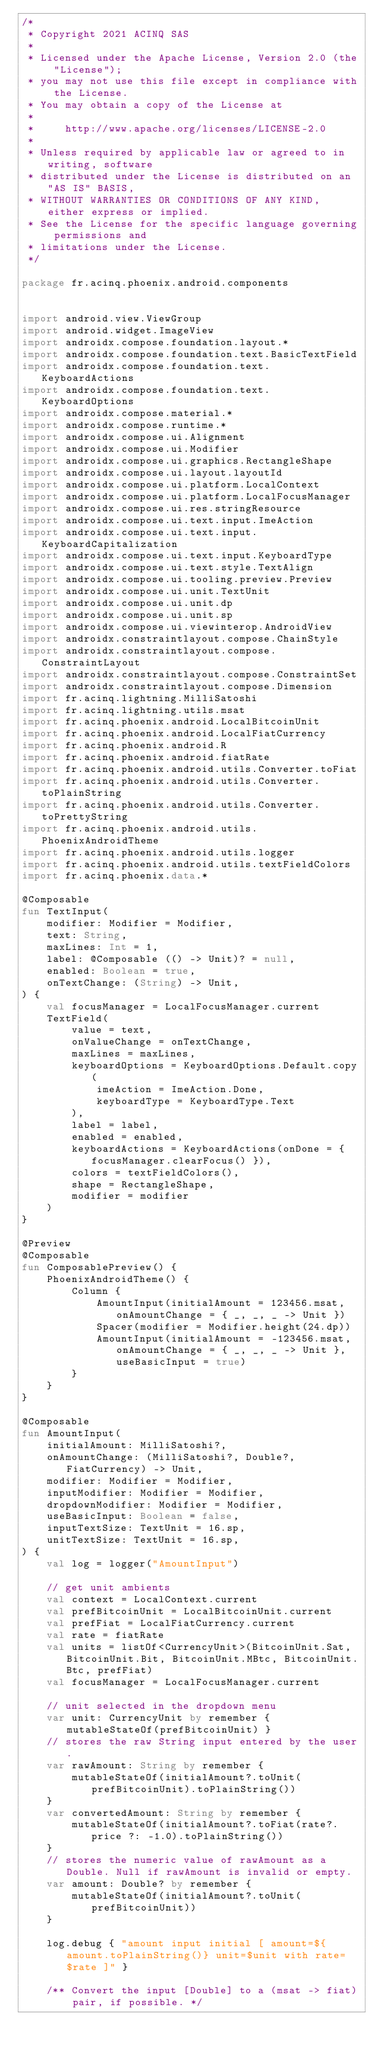Convert code to text. <code><loc_0><loc_0><loc_500><loc_500><_Kotlin_>/*
 * Copyright 2021 ACINQ SAS
 *
 * Licensed under the Apache License, Version 2.0 (the "License");
 * you may not use this file except in compliance with the License.
 * You may obtain a copy of the License at
 *
 *     http://www.apache.org/licenses/LICENSE-2.0
 *
 * Unless required by applicable law or agreed to in writing, software
 * distributed under the License is distributed on an "AS IS" BASIS,
 * WITHOUT WARRANTIES OR CONDITIONS OF ANY KIND, either express or implied.
 * See the License for the specific language governing permissions and
 * limitations under the License.
 */

package fr.acinq.phoenix.android.components


import android.view.ViewGroup
import android.widget.ImageView
import androidx.compose.foundation.layout.*
import androidx.compose.foundation.text.BasicTextField
import androidx.compose.foundation.text.KeyboardActions
import androidx.compose.foundation.text.KeyboardOptions
import androidx.compose.material.*
import androidx.compose.runtime.*
import androidx.compose.ui.Alignment
import androidx.compose.ui.Modifier
import androidx.compose.ui.graphics.RectangleShape
import androidx.compose.ui.layout.layoutId
import androidx.compose.ui.platform.LocalContext
import androidx.compose.ui.platform.LocalFocusManager
import androidx.compose.ui.res.stringResource
import androidx.compose.ui.text.input.ImeAction
import androidx.compose.ui.text.input.KeyboardCapitalization
import androidx.compose.ui.text.input.KeyboardType
import androidx.compose.ui.text.style.TextAlign
import androidx.compose.ui.tooling.preview.Preview
import androidx.compose.ui.unit.TextUnit
import androidx.compose.ui.unit.dp
import androidx.compose.ui.unit.sp
import androidx.compose.ui.viewinterop.AndroidView
import androidx.constraintlayout.compose.ChainStyle
import androidx.constraintlayout.compose.ConstraintLayout
import androidx.constraintlayout.compose.ConstraintSet
import androidx.constraintlayout.compose.Dimension
import fr.acinq.lightning.MilliSatoshi
import fr.acinq.lightning.utils.msat
import fr.acinq.phoenix.android.LocalBitcoinUnit
import fr.acinq.phoenix.android.LocalFiatCurrency
import fr.acinq.phoenix.android.R
import fr.acinq.phoenix.android.fiatRate
import fr.acinq.phoenix.android.utils.Converter.toFiat
import fr.acinq.phoenix.android.utils.Converter.toPlainString
import fr.acinq.phoenix.android.utils.Converter.toPrettyString
import fr.acinq.phoenix.android.utils.PhoenixAndroidTheme
import fr.acinq.phoenix.android.utils.logger
import fr.acinq.phoenix.android.utils.textFieldColors
import fr.acinq.phoenix.data.*

@Composable
fun TextInput(
    modifier: Modifier = Modifier,
    text: String,
    maxLines: Int = 1,
    label: @Composable (() -> Unit)? = null,
    enabled: Boolean = true,
    onTextChange: (String) -> Unit,
) {
    val focusManager = LocalFocusManager.current
    TextField(
        value = text,
        onValueChange = onTextChange,
        maxLines = maxLines,
        keyboardOptions = KeyboardOptions.Default.copy(
            imeAction = ImeAction.Done,
            keyboardType = KeyboardType.Text
        ),
        label = label,
        enabled = enabled,
        keyboardActions = KeyboardActions(onDone = { focusManager.clearFocus() }),
        colors = textFieldColors(),
        shape = RectangleShape,
        modifier = modifier
    )
}

@Preview
@Composable
fun ComposablePreview() {
    PhoenixAndroidTheme() {
        Column {
            AmountInput(initialAmount = 123456.msat, onAmountChange = { _, _, _ -> Unit })
            Spacer(modifier = Modifier.height(24.dp))
            AmountInput(initialAmount = -123456.msat, onAmountChange = { _, _, _ -> Unit }, useBasicInput = true)
        }
    }
}

@Composable
fun AmountInput(
    initialAmount: MilliSatoshi?,
    onAmountChange: (MilliSatoshi?, Double?, FiatCurrency) -> Unit,
    modifier: Modifier = Modifier,
    inputModifier: Modifier = Modifier,
    dropdownModifier: Modifier = Modifier,
    useBasicInput: Boolean = false,
    inputTextSize: TextUnit = 16.sp,
    unitTextSize: TextUnit = 16.sp,
) {
    val log = logger("AmountInput")

    // get unit ambients
    val context = LocalContext.current
    val prefBitcoinUnit = LocalBitcoinUnit.current
    val prefFiat = LocalFiatCurrency.current
    val rate = fiatRate
    val units = listOf<CurrencyUnit>(BitcoinUnit.Sat, BitcoinUnit.Bit, BitcoinUnit.MBtc, BitcoinUnit.Btc, prefFiat)
    val focusManager = LocalFocusManager.current

    // unit selected in the dropdown menu
    var unit: CurrencyUnit by remember { mutableStateOf(prefBitcoinUnit) }
    // stores the raw String input entered by the user.
    var rawAmount: String by remember {
        mutableStateOf(initialAmount?.toUnit(prefBitcoinUnit).toPlainString())
    }
    var convertedAmount: String by remember {
        mutableStateOf(initialAmount?.toFiat(rate?.price ?: -1.0).toPlainString())
    }
    // stores the numeric value of rawAmount as a Double. Null if rawAmount is invalid or empty.
    var amount: Double? by remember {
        mutableStateOf(initialAmount?.toUnit(prefBitcoinUnit))
    }

    log.debug { "amount input initial [ amount=${amount.toPlainString()} unit=$unit with rate=$rate ]" }

    /** Convert the input [Double] to a (msat -> fiat) pair, if possible. */</code> 